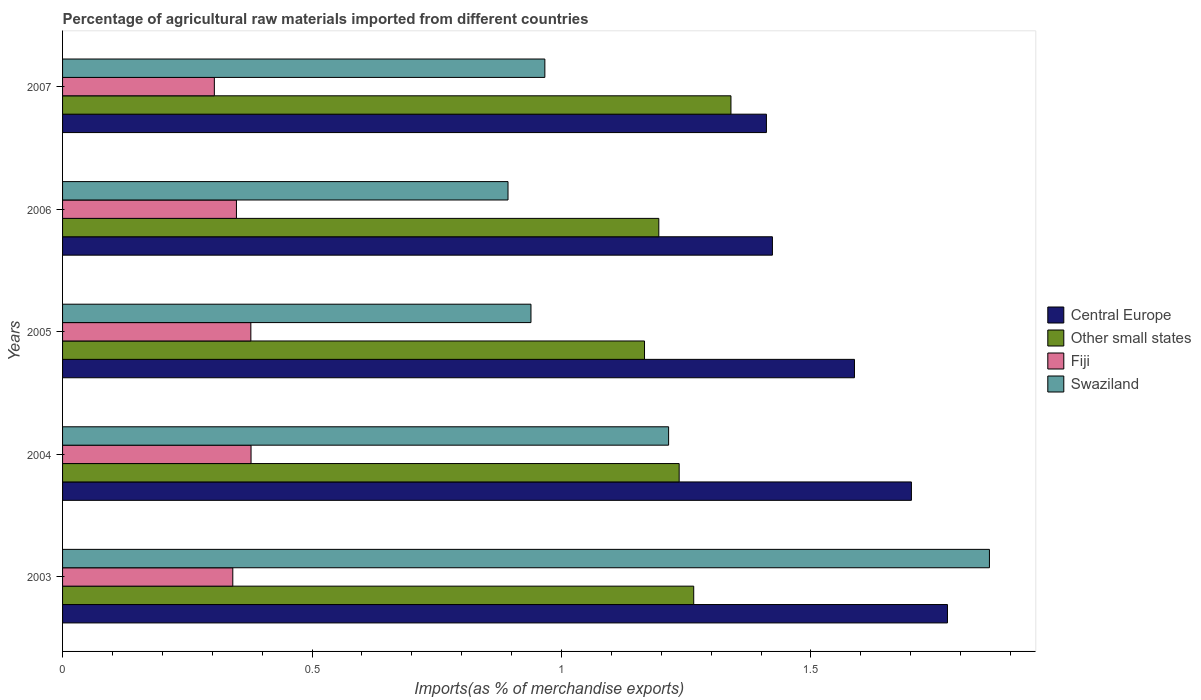How many different coloured bars are there?
Your answer should be very brief. 4. How many groups of bars are there?
Your response must be concise. 5. Are the number of bars per tick equal to the number of legend labels?
Provide a succinct answer. Yes. Are the number of bars on each tick of the Y-axis equal?
Your answer should be very brief. Yes. How many bars are there on the 2nd tick from the top?
Your response must be concise. 4. How many bars are there on the 2nd tick from the bottom?
Your answer should be compact. 4. In how many cases, is the number of bars for a given year not equal to the number of legend labels?
Provide a succinct answer. 0. What is the percentage of imports to different countries in Other small states in 2007?
Ensure brevity in your answer.  1.34. Across all years, what is the maximum percentage of imports to different countries in Central Europe?
Provide a short and direct response. 1.77. Across all years, what is the minimum percentage of imports to different countries in Fiji?
Make the answer very short. 0.3. In which year was the percentage of imports to different countries in Swaziland maximum?
Offer a terse response. 2003. In which year was the percentage of imports to different countries in Other small states minimum?
Offer a very short reply. 2005. What is the total percentage of imports to different countries in Swaziland in the graph?
Your response must be concise. 5.87. What is the difference between the percentage of imports to different countries in Swaziland in 2004 and that in 2005?
Ensure brevity in your answer.  0.28. What is the difference between the percentage of imports to different countries in Fiji in 2005 and the percentage of imports to different countries in Central Europe in 2003?
Keep it short and to the point. -1.4. What is the average percentage of imports to different countries in Fiji per year?
Your response must be concise. 0.35. In the year 2004, what is the difference between the percentage of imports to different countries in Other small states and percentage of imports to different countries in Swaziland?
Provide a succinct answer. 0.02. What is the ratio of the percentage of imports to different countries in Other small states in 2004 to that in 2006?
Keep it short and to the point. 1.03. What is the difference between the highest and the second highest percentage of imports to different countries in Swaziland?
Your answer should be very brief. 0.64. What is the difference between the highest and the lowest percentage of imports to different countries in Central Europe?
Your answer should be compact. 0.36. Is the sum of the percentage of imports to different countries in Swaziland in 2003 and 2004 greater than the maximum percentage of imports to different countries in Central Europe across all years?
Provide a short and direct response. Yes. Is it the case that in every year, the sum of the percentage of imports to different countries in Swaziland and percentage of imports to different countries in Central Europe is greater than the sum of percentage of imports to different countries in Other small states and percentage of imports to different countries in Fiji?
Your answer should be compact. Yes. What does the 3rd bar from the top in 2007 represents?
Your response must be concise. Other small states. What does the 4th bar from the bottom in 2007 represents?
Ensure brevity in your answer.  Swaziland. How many bars are there?
Offer a terse response. 20. Are the values on the major ticks of X-axis written in scientific E-notation?
Your response must be concise. No. How many legend labels are there?
Offer a terse response. 4. What is the title of the graph?
Offer a very short reply. Percentage of agricultural raw materials imported from different countries. What is the label or title of the X-axis?
Provide a short and direct response. Imports(as % of merchandise exports). What is the label or title of the Y-axis?
Your response must be concise. Years. What is the Imports(as % of merchandise exports) of Central Europe in 2003?
Your answer should be very brief. 1.77. What is the Imports(as % of merchandise exports) in Other small states in 2003?
Offer a terse response. 1.27. What is the Imports(as % of merchandise exports) of Fiji in 2003?
Ensure brevity in your answer.  0.34. What is the Imports(as % of merchandise exports) in Swaziland in 2003?
Keep it short and to the point. 1.86. What is the Imports(as % of merchandise exports) in Central Europe in 2004?
Offer a very short reply. 1.7. What is the Imports(as % of merchandise exports) of Other small states in 2004?
Provide a short and direct response. 1.24. What is the Imports(as % of merchandise exports) in Fiji in 2004?
Give a very brief answer. 0.38. What is the Imports(as % of merchandise exports) in Swaziland in 2004?
Keep it short and to the point. 1.21. What is the Imports(as % of merchandise exports) in Central Europe in 2005?
Offer a very short reply. 1.59. What is the Imports(as % of merchandise exports) in Other small states in 2005?
Your response must be concise. 1.17. What is the Imports(as % of merchandise exports) of Fiji in 2005?
Your answer should be very brief. 0.38. What is the Imports(as % of merchandise exports) of Swaziland in 2005?
Make the answer very short. 0.94. What is the Imports(as % of merchandise exports) in Central Europe in 2006?
Your answer should be very brief. 1.42. What is the Imports(as % of merchandise exports) in Other small states in 2006?
Provide a succinct answer. 1.2. What is the Imports(as % of merchandise exports) of Fiji in 2006?
Your response must be concise. 0.35. What is the Imports(as % of merchandise exports) of Swaziland in 2006?
Offer a terse response. 0.89. What is the Imports(as % of merchandise exports) in Central Europe in 2007?
Offer a very short reply. 1.41. What is the Imports(as % of merchandise exports) in Other small states in 2007?
Provide a succinct answer. 1.34. What is the Imports(as % of merchandise exports) of Fiji in 2007?
Your response must be concise. 0.3. What is the Imports(as % of merchandise exports) in Swaziland in 2007?
Offer a very short reply. 0.97. Across all years, what is the maximum Imports(as % of merchandise exports) in Central Europe?
Your answer should be very brief. 1.77. Across all years, what is the maximum Imports(as % of merchandise exports) of Other small states?
Keep it short and to the point. 1.34. Across all years, what is the maximum Imports(as % of merchandise exports) in Fiji?
Give a very brief answer. 0.38. Across all years, what is the maximum Imports(as % of merchandise exports) in Swaziland?
Keep it short and to the point. 1.86. Across all years, what is the minimum Imports(as % of merchandise exports) of Central Europe?
Offer a terse response. 1.41. Across all years, what is the minimum Imports(as % of merchandise exports) of Other small states?
Provide a succinct answer. 1.17. Across all years, what is the minimum Imports(as % of merchandise exports) of Fiji?
Your response must be concise. 0.3. Across all years, what is the minimum Imports(as % of merchandise exports) of Swaziland?
Give a very brief answer. 0.89. What is the total Imports(as % of merchandise exports) in Central Europe in the graph?
Offer a terse response. 7.9. What is the total Imports(as % of merchandise exports) in Other small states in the graph?
Provide a short and direct response. 6.2. What is the total Imports(as % of merchandise exports) of Fiji in the graph?
Make the answer very short. 1.75. What is the total Imports(as % of merchandise exports) in Swaziland in the graph?
Ensure brevity in your answer.  5.87. What is the difference between the Imports(as % of merchandise exports) of Central Europe in 2003 and that in 2004?
Provide a succinct answer. 0.07. What is the difference between the Imports(as % of merchandise exports) of Other small states in 2003 and that in 2004?
Your answer should be compact. 0.03. What is the difference between the Imports(as % of merchandise exports) of Fiji in 2003 and that in 2004?
Provide a short and direct response. -0.04. What is the difference between the Imports(as % of merchandise exports) in Swaziland in 2003 and that in 2004?
Your answer should be compact. 0.64. What is the difference between the Imports(as % of merchandise exports) in Central Europe in 2003 and that in 2005?
Your response must be concise. 0.19. What is the difference between the Imports(as % of merchandise exports) of Other small states in 2003 and that in 2005?
Keep it short and to the point. 0.1. What is the difference between the Imports(as % of merchandise exports) of Fiji in 2003 and that in 2005?
Provide a succinct answer. -0.04. What is the difference between the Imports(as % of merchandise exports) in Swaziland in 2003 and that in 2005?
Your response must be concise. 0.92. What is the difference between the Imports(as % of merchandise exports) in Central Europe in 2003 and that in 2006?
Make the answer very short. 0.35. What is the difference between the Imports(as % of merchandise exports) in Other small states in 2003 and that in 2006?
Provide a short and direct response. 0.07. What is the difference between the Imports(as % of merchandise exports) of Fiji in 2003 and that in 2006?
Offer a terse response. -0.01. What is the difference between the Imports(as % of merchandise exports) of Central Europe in 2003 and that in 2007?
Give a very brief answer. 0.36. What is the difference between the Imports(as % of merchandise exports) in Other small states in 2003 and that in 2007?
Ensure brevity in your answer.  -0.07. What is the difference between the Imports(as % of merchandise exports) in Fiji in 2003 and that in 2007?
Provide a short and direct response. 0.04. What is the difference between the Imports(as % of merchandise exports) of Swaziland in 2003 and that in 2007?
Your answer should be very brief. 0.89. What is the difference between the Imports(as % of merchandise exports) in Central Europe in 2004 and that in 2005?
Provide a succinct answer. 0.11. What is the difference between the Imports(as % of merchandise exports) in Other small states in 2004 and that in 2005?
Give a very brief answer. 0.07. What is the difference between the Imports(as % of merchandise exports) of Swaziland in 2004 and that in 2005?
Keep it short and to the point. 0.28. What is the difference between the Imports(as % of merchandise exports) in Central Europe in 2004 and that in 2006?
Provide a succinct answer. 0.28. What is the difference between the Imports(as % of merchandise exports) in Other small states in 2004 and that in 2006?
Make the answer very short. 0.04. What is the difference between the Imports(as % of merchandise exports) in Fiji in 2004 and that in 2006?
Your response must be concise. 0.03. What is the difference between the Imports(as % of merchandise exports) of Swaziland in 2004 and that in 2006?
Keep it short and to the point. 0.32. What is the difference between the Imports(as % of merchandise exports) in Central Europe in 2004 and that in 2007?
Your response must be concise. 0.29. What is the difference between the Imports(as % of merchandise exports) in Other small states in 2004 and that in 2007?
Make the answer very short. -0.1. What is the difference between the Imports(as % of merchandise exports) in Fiji in 2004 and that in 2007?
Your response must be concise. 0.07. What is the difference between the Imports(as % of merchandise exports) of Swaziland in 2004 and that in 2007?
Your response must be concise. 0.25. What is the difference between the Imports(as % of merchandise exports) of Central Europe in 2005 and that in 2006?
Keep it short and to the point. 0.16. What is the difference between the Imports(as % of merchandise exports) of Other small states in 2005 and that in 2006?
Provide a succinct answer. -0.03. What is the difference between the Imports(as % of merchandise exports) of Fiji in 2005 and that in 2006?
Your answer should be very brief. 0.03. What is the difference between the Imports(as % of merchandise exports) in Swaziland in 2005 and that in 2006?
Offer a very short reply. 0.05. What is the difference between the Imports(as % of merchandise exports) in Central Europe in 2005 and that in 2007?
Ensure brevity in your answer.  0.18. What is the difference between the Imports(as % of merchandise exports) of Other small states in 2005 and that in 2007?
Ensure brevity in your answer.  -0.17. What is the difference between the Imports(as % of merchandise exports) in Fiji in 2005 and that in 2007?
Provide a short and direct response. 0.07. What is the difference between the Imports(as % of merchandise exports) of Swaziland in 2005 and that in 2007?
Provide a succinct answer. -0.03. What is the difference between the Imports(as % of merchandise exports) in Central Europe in 2006 and that in 2007?
Your answer should be very brief. 0.01. What is the difference between the Imports(as % of merchandise exports) of Other small states in 2006 and that in 2007?
Give a very brief answer. -0.14. What is the difference between the Imports(as % of merchandise exports) in Fiji in 2006 and that in 2007?
Keep it short and to the point. 0.04. What is the difference between the Imports(as % of merchandise exports) in Swaziland in 2006 and that in 2007?
Offer a very short reply. -0.07. What is the difference between the Imports(as % of merchandise exports) of Central Europe in 2003 and the Imports(as % of merchandise exports) of Other small states in 2004?
Your answer should be compact. 0.54. What is the difference between the Imports(as % of merchandise exports) of Central Europe in 2003 and the Imports(as % of merchandise exports) of Fiji in 2004?
Offer a terse response. 1.4. What is the difference between the Imports(as % of merchandise exports) in Central Europe in 2003 and the Imports(as % of merchandise exports) in Swaziland in 2004?
Give a very brief answer. 0.56. What is the difference between the Imports(as % of merchandise exports) in Other small states in 2003 and the Imports(as % of merchandise exports) in Fiji in 2004?
Keep it short and to the point. 0.89. What is the difference between the Imports(as % of merchandise exports) in Other small states in 2003 and the Imports(as % of merchandise exports) in Swaziland in 2004?
Your answer should be compact. 0.05. What is the difference between the Imports(as % of merchandise exports) in Fiji in 2003 and the Imports(as % of merchandise exports) in Swaziland in 2004?
Offer a very short reply. -0.87. What is the difference between the Imports(as % of merchandise exports) of Central Europe in 2003 and the Imports(as % of merchandise exports) of Other small states in 2005?
Ensure brevity in your answer.  0.61. What is the difference between the Imports(as % of merchandise exports) in Central Europe in 2003 and the Imports(as % of merchandise exports) in Fiji in 2005?
Keep it short and to the point. 1.4. What is the difference between the Imports(as % of merchandise exports) in Central Europe in 2003 and the Imports(as % of merchandise exports) in Swaziland in 2005?
Keep it short and to the point. 0.83. What is the difference between the Imports(as % of merchandise exports) in Other small states in 2003 and the Imports(as % of merchandise exports) in Fiji in 2005?
Provide a short and direct response. 0.89. What is the difference between the Imports(as % of merchandise exports) in Other small states in 2003 and the Imports(as % of merchandise exports) in Swaziland in 2005?
Ensure brevity in your answer.  0.33. What is the difference between the Imports(as % of merchandise exports) of Fiji in 2003 and the Imports(as % of merchandise exports) of Swaziland in 2005?
Offer a very short reply. -0.6. What is the difference between the Imports(as % of merchandise exports) in Central Europe in 2003 and the Imports(as % of merchandise exports) in Other small states in 2006?
Your answer should be compact. 0.58. What is the difference between the Imports(as % of merchandise exports) of Central Europe in 2003 and the Imports(as % of merchandise exports) of Fiji in 2006?
Your answer should be very brief. 1.43. What is the difference between the Imports(as % of merchandise exports) in Central Europe in 2003 and the Imports(as % of merchandise exports) in Swaziland in 2006?
Your response must be concise. 0.88. What is the difference between the Imports(as % of merchandise exports) in Other small states in 2003 and the Imports(as % of merchandise exports) in Fiji in 2006?
Provide a succinct answer. 0.92. What is the difference between the Imports(as % of merchandise exports) of Other small states in 2003 and the Imports(as % of merchandise exports) of Swaziland in 2006?
Keep it short and to the point. 0.37. What is the difference between the Imports(as % of merchandise exports) of Fiji in 2003 and the Imports(as % of merchandise exports) of Swaziland in 2006?
Provide a succinct answer. -0.55. What is the difference between the Imports(as % of merchandise exports) in Central Europe in 2003 and the Imports(as % of merchandise exports) in Other small states in 2007?
Keep it short and to the point. 0.43. What is the difference between the Imports(as % of merchandise exports) of Central Europe in 2003 and the Imports(as % of merchandise exports) of Fiji in 2007?
Give a very brief answer. 1.47. What is the difference between the Imports(as % of merchandise exports) in Central Europe in 2003 and the Imports(as % of merchandise exports) in Swaziland in 2007?
Your answer should be compact. 0.81. What is the difference between the Imports(as % of merchandise exports) of Other small states in 2003 and the Imports(as % of merchandise exports) of Fiji in 2007?
Your response must be concise. 0.96. What is the difference between the Imports(as % of merchandise exports) of Other small states in 2003 and the Imports(as % of merchandise exports) of Swaziland in 2007?
Your answer should be compact. 0.3. What is the difference between the Imports(as % of merchandise exports) in Fiji in 2003 and the Imports(as % of merchandise exports) in Swaziland in 2007?
Provide a succinct answer. -0.63. What is the difference between the Imports(as % of merchandise exports) of Central Europe in 2004 and the Imports(as % of merchandise exports) of Other small states in 2005?
Your response must be concise. 0.54. What is the difference between the Imports(as % of merchandise exports) of Central Europe in 2004 and the Imports(as % of merchandise exports) of Fiji in 2005?
Make the answer very short. 1.32. What is the difference between the Imports(as % of merchandise exports) in Central Europe in 2004 and the Imports(as % of merchandise exports) in Swaziland in 2005?
Your answer should be very brief. 0.76. What is the difference between the Imports(as % of merchandise exports) of Other small states in 2004 and the Imports(as % of merchandise exports) of Fiji in 2005?
Offer a very short reply. 0.86. What is the difference between the Imports(as % of merchandise exports) in Other small states in 2004 and the Imports(as % of merchandise exports) in Swaziland in 2005?
Give a very brief answer. 0.3. What is the difference between the Imports(as % of merchandise exports) of Fiji in 2004 and the Imports(as % of merchandise exports) of Swaziland in 2005?
Offer a terse response. -0.56. What is the difference between the Imports(as % of merchandise exports) in Central Europe in 2004 and the Imports(as % of merchandise exports) in Other small states in 2006?
Ensure brevity in your answer.  0.51. What is the difference between the Imports(as % of merchandise exports) in Central Europe in 2004 and the Imports(as % of merchandise exports) in Fiji in 2006?
Provide a short and direct response. 1.35. What is the difference between the Imports(as % of merchandise exports) in Central Europe in 2004 and the Imports(as % of merchandise exports) in Swaziland in 2006?
Ensure brevity in your answer.  0.81. What is the difference between the Imports(as % of merchandise exports) of Other small states in 2004 and the Imports(as % of merchandise exports) of Fiji in 2006?
Offer a terse response. 0.89. What is the difference between the Imports(as % of merchandise exports) in Other small states in 2004 and the Imports(as % of merchandise exports) in Swaziland in 2006?
Make the answer very short. 0.34. What is the difference between the Imports(as % of merchandise exports) in Fiji in 2004 and the Imports(as % of merchandise exports) in Swaziland in 2006?
Your answer should be compact. -0.52. What is the difference between the Imports(as % of merchandise exports) in Central Europe in 2004 and the Imports(as % of merchandise exports) in Other small states in 2007?
Provide a short and direct response. 0.36. What is the difference between the Imports(as % of merchandise exports) of Central Europe in 2004 and the Imports(as % of merchandise exports) of Fiji in 2007?
Your answer should be compact. 1.4. What is the difference between the Imports(as % of merchandise exports) in Central Europe in 2004 and the Imports(as % of merchandise exports) in Swaziland in 2007?
Your response must be concise. 0.73. What is the difference between the Imports(as % of merchandise exports) in Other small states in 2004 and the Imports(as % of merchandise exports) in Fiji in 2007?
Your answer should be compact. 0.93. What is the difference between the Imports(as % of merchandise exports) of Other small states in 2004 and the Imports(as % of merchandise exports) of Swaziland in 2007?
Give a very brief answer. 0.27. What is the difference between the Imports(as % of merchandise exports) of Fiji in 2004 and the Imports(as % of merchandise exports) of Swaziland in 2007?
Offer a very short reply. -0.59. What is the difference between the Imports(as % of merchandise exports) of Central Europe in 2005 and the Imports(as % of merchandise exports) of Other small states in 2006?
Your answer should be very brief. 0.39. What is the difference between the Imports(as % of merchandise exports) of Central Europe in 2005 and the Imports(as % of merchandise exports) of Fiji in 2006?
Keep it short and to the point. 1.24. What is the difference between the Imports(as % of merchandise exports) in Central Europe in 2005 and the Imports(as % of merchandise exports) in Swaziland in 2006?
Keep it short and to the point. 0.69. What is the difference between the Imports(as % of merchandise exports) of Other small states in 2005 and the Imports(as % of merchandise exports) of Fiji in 2006?
Your answer should be very brief. 0.82. What is the difference between the Imports(as % of merchandise exports) of Other small states in 2005 and the Imports(as % of merchandise exports) of Swaziland in 2006?
Your answer should be very brief. 0.27. What is the difference between the Imports(as % of merchandise exports) of Fiji in 2005 and the Imports(as % of merchandise exports) of Swaziland in 2006?
Offer a very short reply. -0.52. What is the difference between the Imports(as % of merchandise exports) in Central Europe in 2005 and the Imports(as % of merchandise exports) in Other small states in 2007?
Your answer should be compact. 0.25. What is the difference between the Imports(as % of merchandise exports) of Central Europe in 2005 and the Imports(as % of merchandise exports) of Fiji in 2007?
Keep it short and to the point. 1.28. What is the difference between the Imports(as % of merchandise exports) of Central Europe in 2005 and the Imports(as % of merchandise exports) of Swaziland in 2007?
Your answer should be compact. 0.62. What is the difference between the Imports(as % of merchandise exports) in Other small states in 2005 and the Imports(as % of merchandise exports) in Fiji in 2007?
Your response must be concise. 0.86. What is the difference between the Imports(as % of merchandise exports) in Other small states in 2005 and the Imports(as % of merchandise exports) in Swaziland in 2007?
Your response must be concise. 0.2. What is the difference between the Imports(as % of merchandise exports) in Fiji in 2005 and the Imports(as % of merchandise exports) in Swaziland in 2007?
Give a very brief answer. -0.59. What is the difference between the Imports(as % of merchandise exports) in Central Europe in 2006 and the Imports(as % of merchandise exports) in Other small states in 2007?
Your response must be concise. 0.08. What is the difference between the Imports(as % of merchandise exports) in Central Europe in 2006 and the Imports(as % of merchandise exports) in Fiji in 2007?
Offer a terse response. 1.12. What is the difference between the Imports(as % of merchandise exports) of Central Europe in 2006 and the Imports(as % of merchandise exports) of Swaziland in 2007?
Ensure brevity in your answer.  0.46. What is the difference between the Imports(as % of merchandise exports) in Other small states in 2006 and the Imports(as % of merchandise exports) in Fiji in 2007?
Ensure brevity in your answer.  0.89. What is the difference between the Imports(as % of merchandise exports) of Other small states in 2006 and the Imports(as % of merchandise exports) of Swaziland in 2007?
Offer a very short reply. 0.23. What is the difference between the Imports(as % of merchandise exports) in Fiji in 2006 and the Imports(as % of merchandise exports) in Swaziland in 2007?
Your answer should be compact. -0.62. What is the average Imports(as % of merchandise exports) in Central Europe per year?
Ensure brevity in your answer.  1.58. What is the average Imports(as % of merchandise exports) of Other small states per year?
Offer a terse response. 1.24. What is the average Imports(as % of merchandise exports) of Fiji per year?
Make the answer very short. 0.35. What is the average Imports(as % of merchandise exports) of Swaziland per year?
Keep it short and to the point. 1.17. In the year 2003, what is the difference between the Imports(as % of merchandise exports) of Central Europe and Imports(as % of merchandise exports) of Other small states?
Offer a terse response. 0.51. In the year 2003, what is the difference between the Imports(as % of merchandise exports) of Central Europe and Imports(as % of merchandise exports) of Fiji?
Your answer should be very brief. 1.43. In the year 2003, what is the difference between the Imports(as % of merchandise exports) of Central Europe and Imports(as % of merchandise exports) of Swaziland?
Your answer should be very brief. -0.08. In the year 2003, what is the difference between the Imports(as % of merchandise exports) in Other small states and Imports(as % of merchandise exports) in Fiji?
Your answer should be compact. 0.92. In the year 2003, what is the difference between the Imports(as % of merchandise exports) in Other small states and Imports(as % of merchandise exports) in Swaziland?
Give a very brief answer. -0.59. In the year 2003, what is the difference between the Imports(as % of merchandise exports) in Fiji and Imports(as % of merchandise exports) in Swaziland?
Provide a short and direct response. -1.52. In the year 2004, what is the difference between the Imports(as % of merchandise exports) in Central Europe and Imports(as % of merchandise exports) in Other small states?
Provide a succinct answer. 0.47. In the year 2004, what is the difference between the Imports(as % of merchandise exports) in Central Europe and Imports(as % of merchandise exports) in Fiji?
Your response must be concise. 1.32. In the year 2004, what is the difference between the Imports(as % of merchandise exports) of Central Europe and Imports(as % of merchandise exports) of Swaziland?
Your answer should be very brief. 0.49. In the year 2004, what is the difference between the Imports(as % of merchandise exports) in Other small states and Imports(as % of merchandise exports) in Fiji?
Make the answer very short. 0.86. In the year 2004, what is the difference between the Imports(as % of merchandise exports) of Other small states and Imports(as % of merchandise exports) of Swaziland?
Provide a short and direct response. 0.02. In the year 2004, what is the difference between the Imports(as % of merchandise exports) of Fiji and Imports(as % of merchandise exports) of Swaziland?
Keep it short and to the point. -0.84. In the year 2005, what is the difference between the Imports(as % of merchandise exports) of Central Europe and Imports(as % of merchandise exports) of Other small states?
Offer a very short reply. 0.42. In the year 2005, what is the difference between the Imports(as % of merchandise exports) in Central Europe and Imports(as % of merchandise exports) in Fiji?
Offer a very short reply. 1.21. In the year 2005, what is the difference between the Imports(as % of merchandise exports) of Central Europe and Imports(as % of merchandise exports) of Swaziland?
Your answer should be compact. 0.65. In the year 2005, what is the difference between the Imports(as % of merchandise exports) in Other small states and Imports(as % of merchandise exports) in Fiji?
Your answer should be very brief. 0.79. In the year 2005, what is the difference between the Imports(as % of merchandise exports) of Other small states and Imports(as % of merchandise exports) of Swaziland?
Offer a very short reply. 0.23. In the year 2005, what is the difference between the Imports(as % of merchandise exports) in Fiji and Imports(as % of merchandise exports) in Swaziland?
Give a very brief answer. -0.56. In the year 2006, what is the difference between the Imports(as % of merchandise exports) of Central Europe and Imports(as % of merchandise exports) of Other small states?
Your answer should be very brief. 0.23. In the year 2006, what is the difference between the Imports(as % of merchandise exports) in Central Europe and Imports(as % of merchandise exports) in Fiji?
Ensure brevity in your answer.  1.07. In the year 2006, what is the difference between the Imports(as % of merchandise exports) of Central Europe and Imports(as % of merchandise exports) of Swaziland?
Keep it short and to the point. 0.53. In the year 2006, what is the difference between the Imports(as % of merchandise exports) in Other small states and Imports(as % of merchandise exports) in Fiji?
Give a very brief answer. 0.85. In the year 2006, what is the difference between the Imports(as % of merchandise exports) of Other small states and Imports(as % of merchandise exports) of Swaziland?
Ensure brevity in your answer.  0.3. In the year 2006, what is the difference between the Imports(as % of merchandise exports) in Fiji and Imports(as % of merchandise exports) in Swaziland?
Offer a terse response. -0.54. In the year 2007, what is the difference between the Imports(as % of merchandise exports) of Central Europe and Imports(as % of merchandise exports) of Other small states?
Your response must be concise. 0.07. In the year 2007, what is the difference between the Imports(as % of merchandise exports) in Central Europe and Imports(as % of merchandise exports) in Fiji?
Provide a succinct answer. 1.11. In the year 2007, what is the difference between the Imports(as % of merchandise exports) in Central Europe and Imports(as % of merchandise exports) in Swaziland?
Give a very brief answer. 0.44. In the year 2007, what is the difference between the Imports(as % of merchandise exports) of Other small states and Imports(as % of merchandise exports) of Fiji?
Offer a very short reply. 1.04. In the year 2007, what is the difference between the Imports(as % of merchandise exports) in Other small states and Imports(as % of merchandise exports) in Swaziland?
Your answer should be very brief. 0.37. In the year 2007, what is the difference between the Imports(as % of merchandise exports) of Fiji and Imports(as % of merchandise exports) of Swaziland?
Make the answer very short. -0.66. What is the ratio of the Imports(as % of merchandise exports) of Central Europe in 2003 to that in 2004?
Make the answer very short. 1.04. What is the ratio of the Imports(as % of merchandise exports) in Other small states in 2003 to that in 2004?
Give a very brief answer. 1.02. What is the ratio of the Imports(as % of merchandise exports) in Fiji in 2003 to that in 2004?
Keep it short and to the point. 0.9. What is the ratio of the Imports(as % of merchandise exports) of Swaziland in 2003 to that in 2004?
Offer a very short reply. 1.53. What is the ratio of the Imports(as % of merchandise exports) in Central Europe in 2003 to that in 2005?
Your response must be concise. 1.12. What is the ratio of the Imports(as % of merchandise exports) of Other small states in 2003 to that in 2005?
Give a very brief answer. 1.08. What is the ratio of the Imports(as % of merchandise exports) in Fiji in 2003 to that in 2005?
Offer a terse response. 0.9. What is the ratio of the Imports(as % of merchandise exports) in Swaziland in 2003 to that in 2005?
Your answer should be compact. 1.98. What is the ratio of the Imports(as % of merchandise exports) in Central Europe in 2003 to that in 2006?
Make the answer very short. 1.25. What is the ratio of the Imports(as % of merchandise exports) in Other small states in 2003 to that in 2006?
Offer a very short reply. 1.06. What is the ratio of the Imports(as % of merchandise exports) in Fiji in 2003 to that in 2006?
Keep it short and to the point. 0.98. What is the ratio of the Imports(as % of merchandise exports) in Swaziland in 2003 to that in 2006?
Give a very brief answer. 2.08. What is the ratio of the Imports(as % of merchandise exports) of Central Europe in 2003 to that in 2007?
Provide a succinct answer. 1.26. What is the ratio of the Imports(as % of merchandise exports) in Other small states in 2003 to that in 2007?
Your response must be concise. 0.94. What is the ratio of the Imports(as % of merchandise exports) in Fiji in 2003 to that in 2007?
Your answer should be very brief. 1.12. What is the ratio of the Imports(as % of merchandise exports) in Swaziland in 2003 to that in 2007?
Give a very brief answer. 1.92. What is the ratio of the Imports(as % of merchandise exports) of Central Europe in 2004 to that in 2005?
Make the answer very short. 1.07. What is the ratio of the Imports(as % of merchandise exports) in Other small states in 2004 to that in 2005?
Give a very brief answer. 1.06. What is the ratio of the Imports(as % of merchandise exports) of Fiji in 2004 to that in 2005?
Your response must be concise. 1. What is the ratio of the Imports(as % of merchandise exports) of Swaziland in 2004 to that in 2005?
Offer a very short reply. 1.29. What is the ratio of the Imports(as % of merchandise exports) in Central Europe in 2004 to that in 2006?
Keep it short and to the point. 1.2. What is the ratio of the Imports(as % of merchandise exports) of Other small states in 2004 to that in 2006?
Your answer should be very brief. 1.03. What is the ratio of the Imports(as % of merchandise exports) in Fiji in 2004 to that in 2006?
Your answer should be very brief. 1.08. What is the ratio of the Imports(as % of merchandise exports) of Swaziland in 2004 to that in 2006?
Keep it short and to the point. 1.36. What is the ratio of the Imports(as % of merchandise exports) in Central Europe in 2004 to that in 2007?
Your response must be concise. 1.21. What is the ratio of the Imports(as % of merchandise exports) in Other small states in 2004 to that in 2007?
Offer a terse response. 0.92. What is the ratio of the Imports(as % of merchandise exports) in Fiji in 2004 to that in 2007?
Offer a very short reply. 1.24. What is the ratio of the Imports(as % of merchandise exports) in Swaziland in 2004 to that in 2007?
Your answer should be compact. 1.26. What is the ratio of the Imports(as % of merchandise exports) in Central Europe in 2005 to that in 2006?
Offer a terse response. 1.12. What is the ratio of the Imports(as % of merchandise exports) in Other small states in 2005 to that in 2006?
Ensure brevity in your answer.  0.98. What is the ratio of the Imports(as % of merchandise exports) in Fiji in 2005 to that in 2006?
Make the answer very short. 1.08. What is the ratio of the Imports(as % of merchandise exports) of Swaziland in 2005 to that in 2006?
Offer a very short reply. 1.05. What is the ratio of the Imports(as % of merchandise exports) of Central Europe in 2005 to that in 2007?
Ensure brevity in your answer.  1.13. What is the ratio of the Imports(as % of merchandise exports) of Other small states in 2005 to that in 2007?
Your answer should be very brief. 0.87. What is the ratio of the Imports(as % of merchandise exports) in Fiji in 2005 to that in 2007?
Offer a terse response. 1.24. What is the ratio of the Imports(as % of merchandise exports) of Swaziland in 2005 to that in 2007?
Your response must be concise. 0.97. What is the ratio of the Imports(as % of merchandise exports) of Central Europe in 2006 to that in 2007?
Give a very brief answer. 1.01. What is the ratio of the Imports(as % of merchandise exports) in Other small states in 2006 to that in 2007?
Your answer should be very brief. 0.89. What is the ratio of the Imports(as % of merchandise exports) in Fiji in 2006 to that in 2007?
Your answer should be very brief. 1.15. What is the ratio of the Imports(as % of merchandise exports) in Swaziland in 2006 to that in 2007?
Provide a short and direct response. 0.92. What is the difference between the highest and the second highest Imports(as % of merchandise exports) of Central Europe?
Offer a very short reply. 0.07. What is the difference between the highest and the second highest Imports(as % of merchandise exports) of Other small states?
Make the answer very short. 0.07. What is the difference between the highest and the second highest Imports(as % of merchandise exports) of Swaziland?
Give a very brief answer. 0.64. What is the difference between the highest and the lowest Imports(as % of merchandise exports) of Central Europe?
Offer a very short reply. 0.36. What is the difference between the highest and the lowest Imports(as % of merchandise exports) in Other small states?
Ensure brevity in your answer.  0.17. What is the difference between the highest and the lowest Imports(as % of merchandise exports) in Fiji?
Make the answer very short. 0.07. What is the difference between the highest and the lowest Imports(as % of merchandise exports) in Swaziland?
Your answer should be very brief. 0.96. 